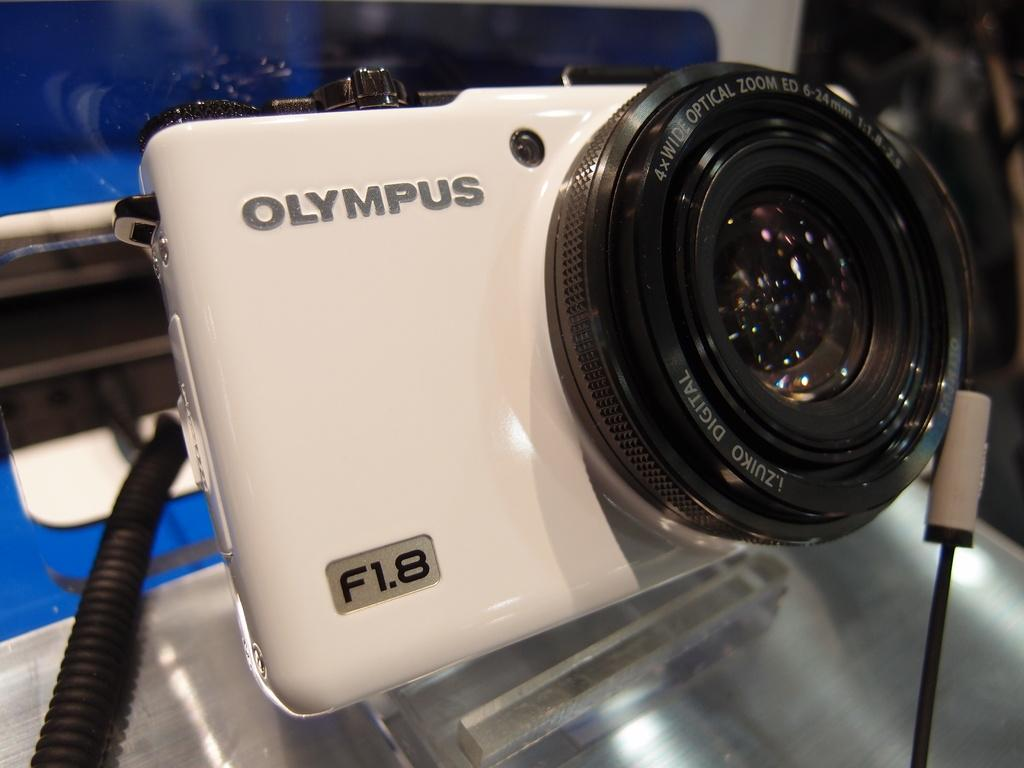Where was the image taken? The image was taken indoors. What is located at the bottom of the image? There is a table at the bottom of the image. What object can be seen on the table? There is a camera on the table. What type of grass can be seen growing on the table in the image? There is no grass present in the image; it is taken indoors and features a table with a camera on it. 